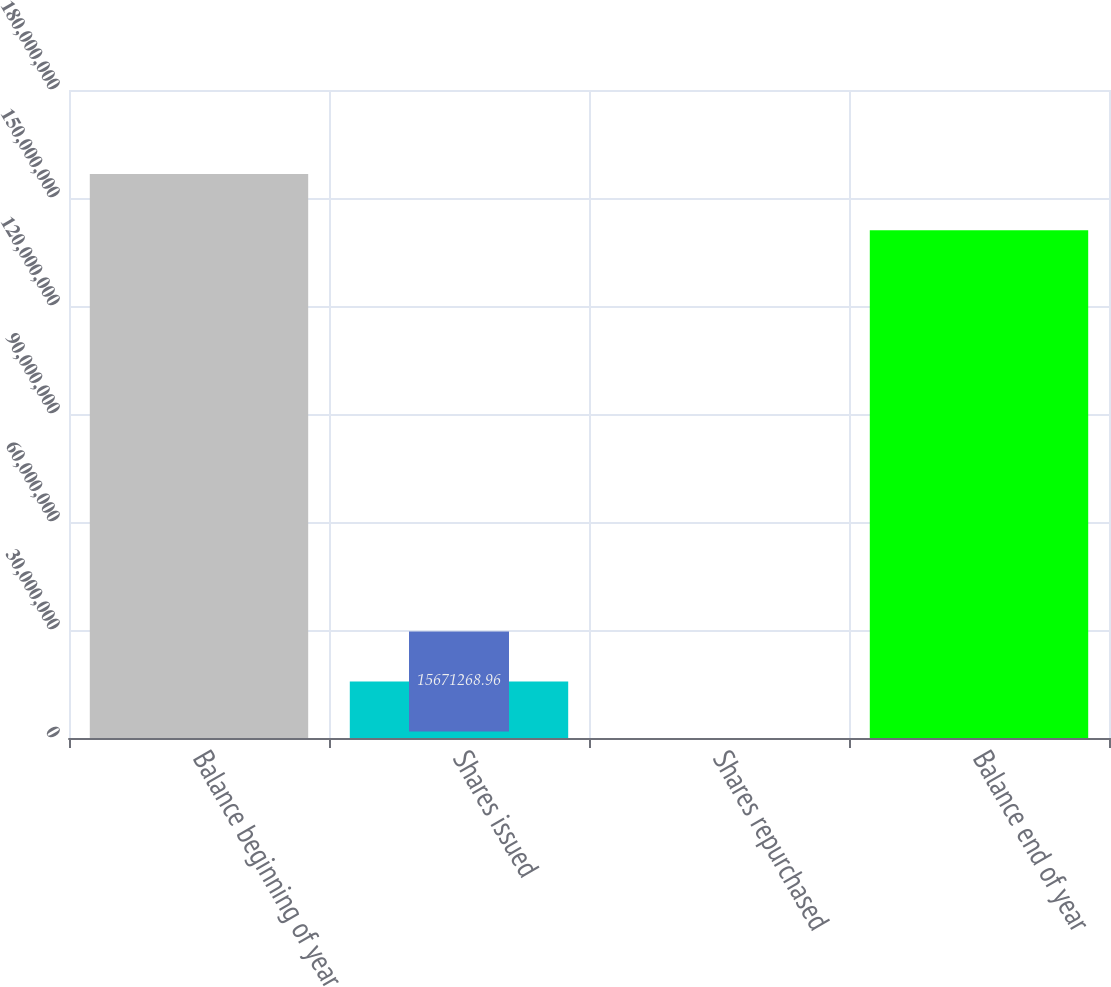<chart> <loc_0><loc_0><loc_500><loc_500><bar_chart><fcel>Balance beginning of year<fcel>Shares issued<fcel>Shares repurchased<fcel>Balance end of year<nl><fcel>1.56663e+08<fcel>1.56713e+07<fcel>17815<fcel>1.4101e+08<nl></chart> 